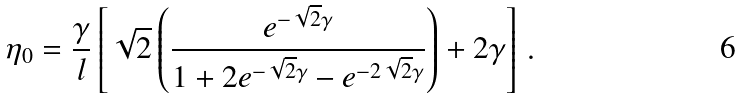<formula> <loc_0><loc_0><loc_500><loc_500>\eta _ { 0 } = \frac { \gamma } { l } \left [ \sqrt { 2 } \left ( \frac { e ^ { - \sqrt { 2 } \gamma } } { 1 + 2 e ^ { - \sqrt { 2 } \gamma } - e ^ { - 2 \sqrt { 2 } \gamma } } \right ) + 2 \gamma \right ] \, .</formula> 